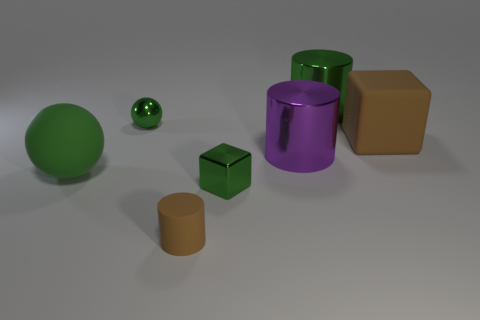What number of rubber balls have the same size as the purple metallic cylinder?
Provide a succinct answer. 1. What shape is the purple thing that is made of the same material as the green cube?
Ensure brevity in your answer.  Cylinder. Are there any large rubber things that have the same color as the small metallic sphere?
Give a very brief answer. Yes. What is the material of the purple object?
Offer a terse response. Metal. How many things are either tiny matte cylinders or tiny cubes?
Make the answer very short. 2. What size is the matte cube in front of the large green shiny thing?
Provide a short and direct response. Large. How many other things are there of the same material as the brown cube?
Your answer should be very brief. 2. Is there a large green rubber object in front of the rubber object that is to the right of the large green cylinder?
Offer a very short reply. Yes. Are there any other things that have the same shape as the big brown rubber object?
Make the answer very short. Yes. The other large object that is the same shape as the purple metal thing is what color?
Make the answer very short. Green. 